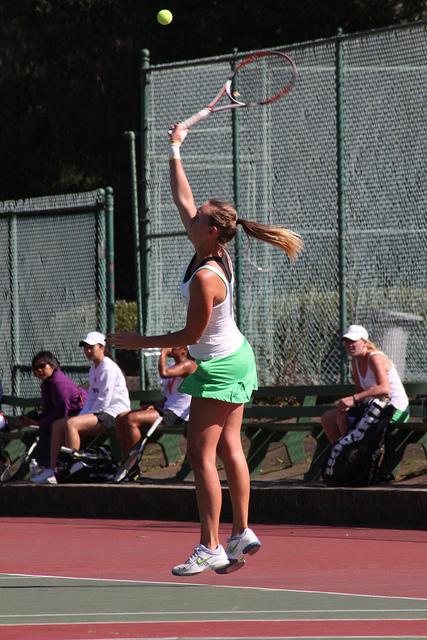Is she going to hit the ball?
Keep it brief. Yes. How is the player's hair fixed?
Write a very short answer. Ponytail. What color shorts is the tennis player wearing?
Give a very brief answer. Green. 